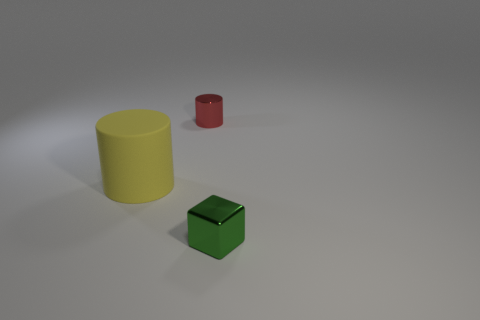Add 3 cyan blocks. How many objects exist? 6 Subtract all cylinders. How many objects are left? 1 Add 1 big cylinders. How many big cylinders exist? 2 Subtract 0 purple balls. How many objects are left? 3 Subtract all big yellow shiny blocks. Subtract all small green metallic blocks. How many objects are left? 2 Add 2 tiny green metal things. How many tiny green metal things are left? 3 